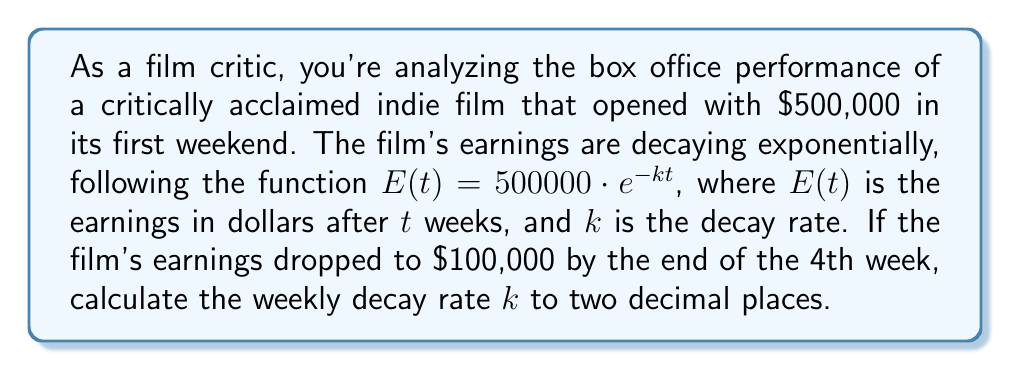Help me with this question. Let's approach this step-by-step:

1) We're given the exponential decay function: $E(t) = 500000 \cdot e^{-kt}$

2) We know two points:
   At $t = 0$, $E(0) = 500000$
   At $t = 4$, $E(4) = 100000$

3) Let's plug in the values for the second point:

   $100000 = 500000 \cdot e^{-k(4)}$

4) Divide both sides by 500000:

   $\frac{1}{5} = e^{-4k}$

5) Take the natural log of both sides:

   $\ln(\frac{1}{5}) = \ln(e^{-4k})$

6) Simplify the right side using the properties of logarithms:

   $\ln(\frac{1}{5}) = -4k$

7) Solve for $k$:

   $k = -\frac{1}{4}\ln(\frac{1}{5})$

8) Calculate:
   $k = -\frac{1}{4}(-1.6094...) \approx 0.4023$

9) Rounding to two decimal places:

   $k \approx 0.40$

This decay rate means that each week, the earnings decrease by about 40% compared to the previous week.
Answer: $k \approx 0.40$ 